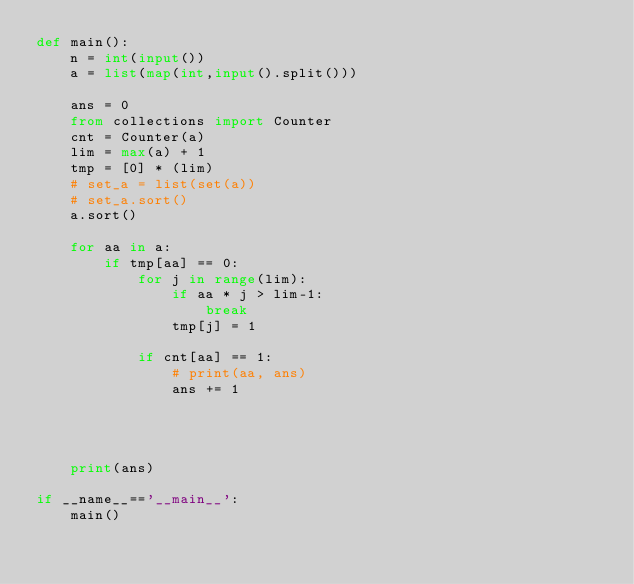<code> <loc_0><loc_0><loc_500><loc_500><_Python_>def main():
    n = int(input())
    a = list(map(int,input().split()))

    ans = 0
    from collections import Counter
    cnt = Counter(a)
    lim = max(a) + 1
    tmp = [0] * (lim)
    # set_a = list(set(a))
    # set_a.sort()
    a.sort()

    for aa in a:
        if tmp[aa] == 0:
            for j in range(lim):
                if aa * j > lim-1:
                    break
                tmp[j] = 1

            if cnt[aa] == 1:
                # print(aa, ans)
                ans += 1




    print(ans)

if __name__=='__main__':
    main()
</code> 